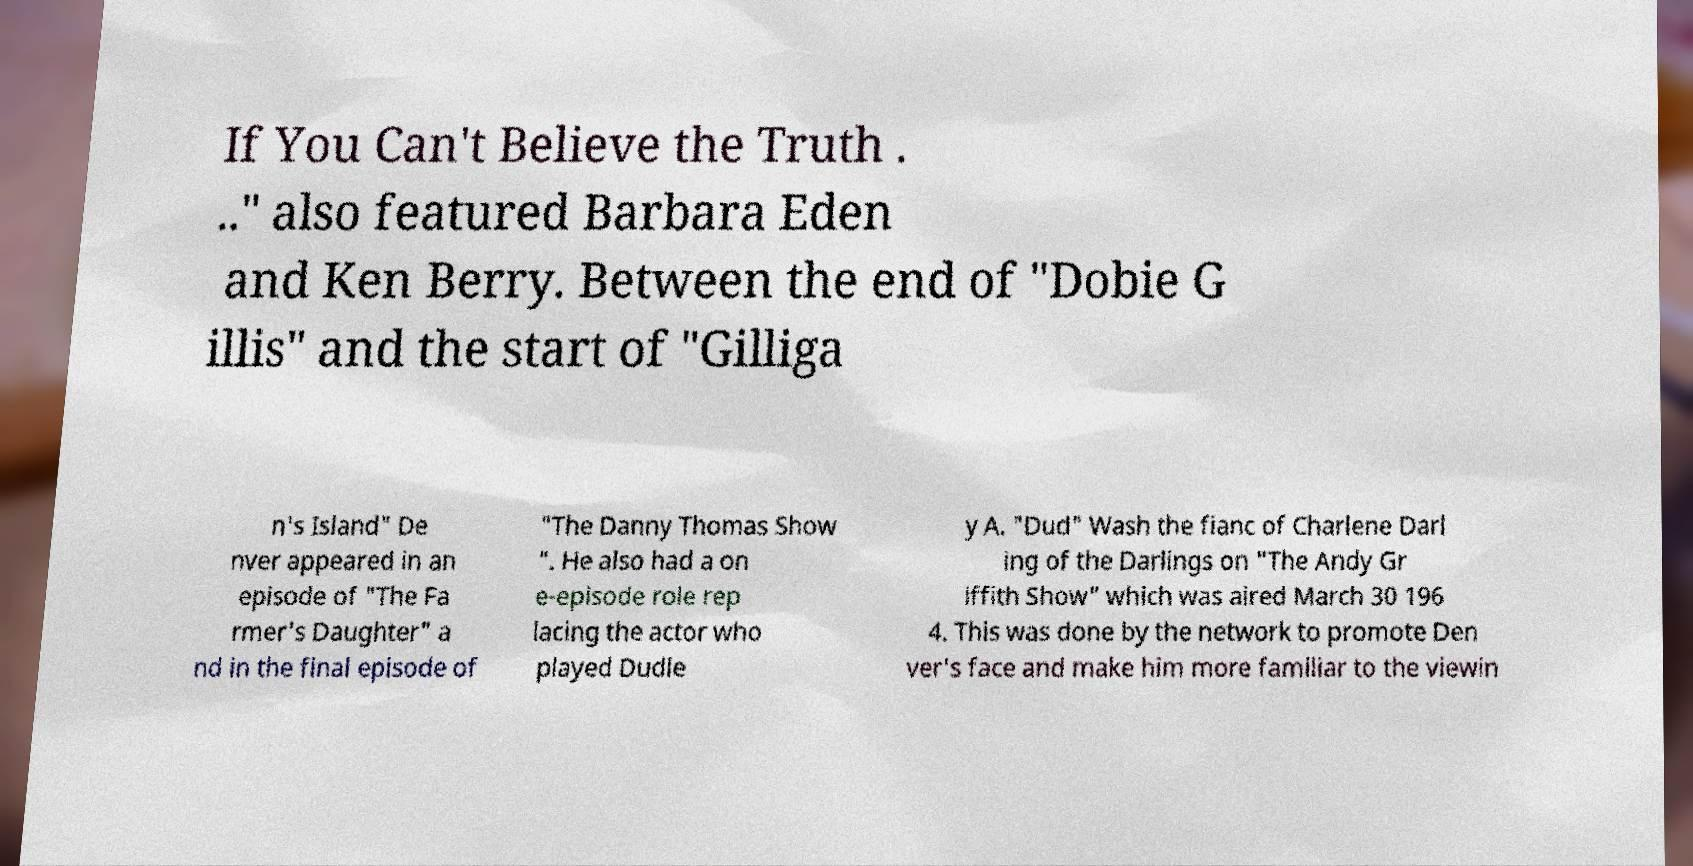Could you extract and type out the text from this image? If You Can't Believe the Truth . .." also featured Barbara Eden and Ken Berry. Between the end of "Dobie G illis" and the start of "Gilliga n's Island" De nver appeared in an episode of "The Fa rmer's Daughter" a nd in the final episode of "The Danny Thomas Show ". He also had a on e-episode role rep lacing the actor who played Dudle y A. "Dud" Wash the fianc of Charlene Darl ing of the Darlings on "The Andy Gr iffith Show" which was aired March 30 196 4. This was done by the network to promote Den ver's face and make him more familiar to the viewin 